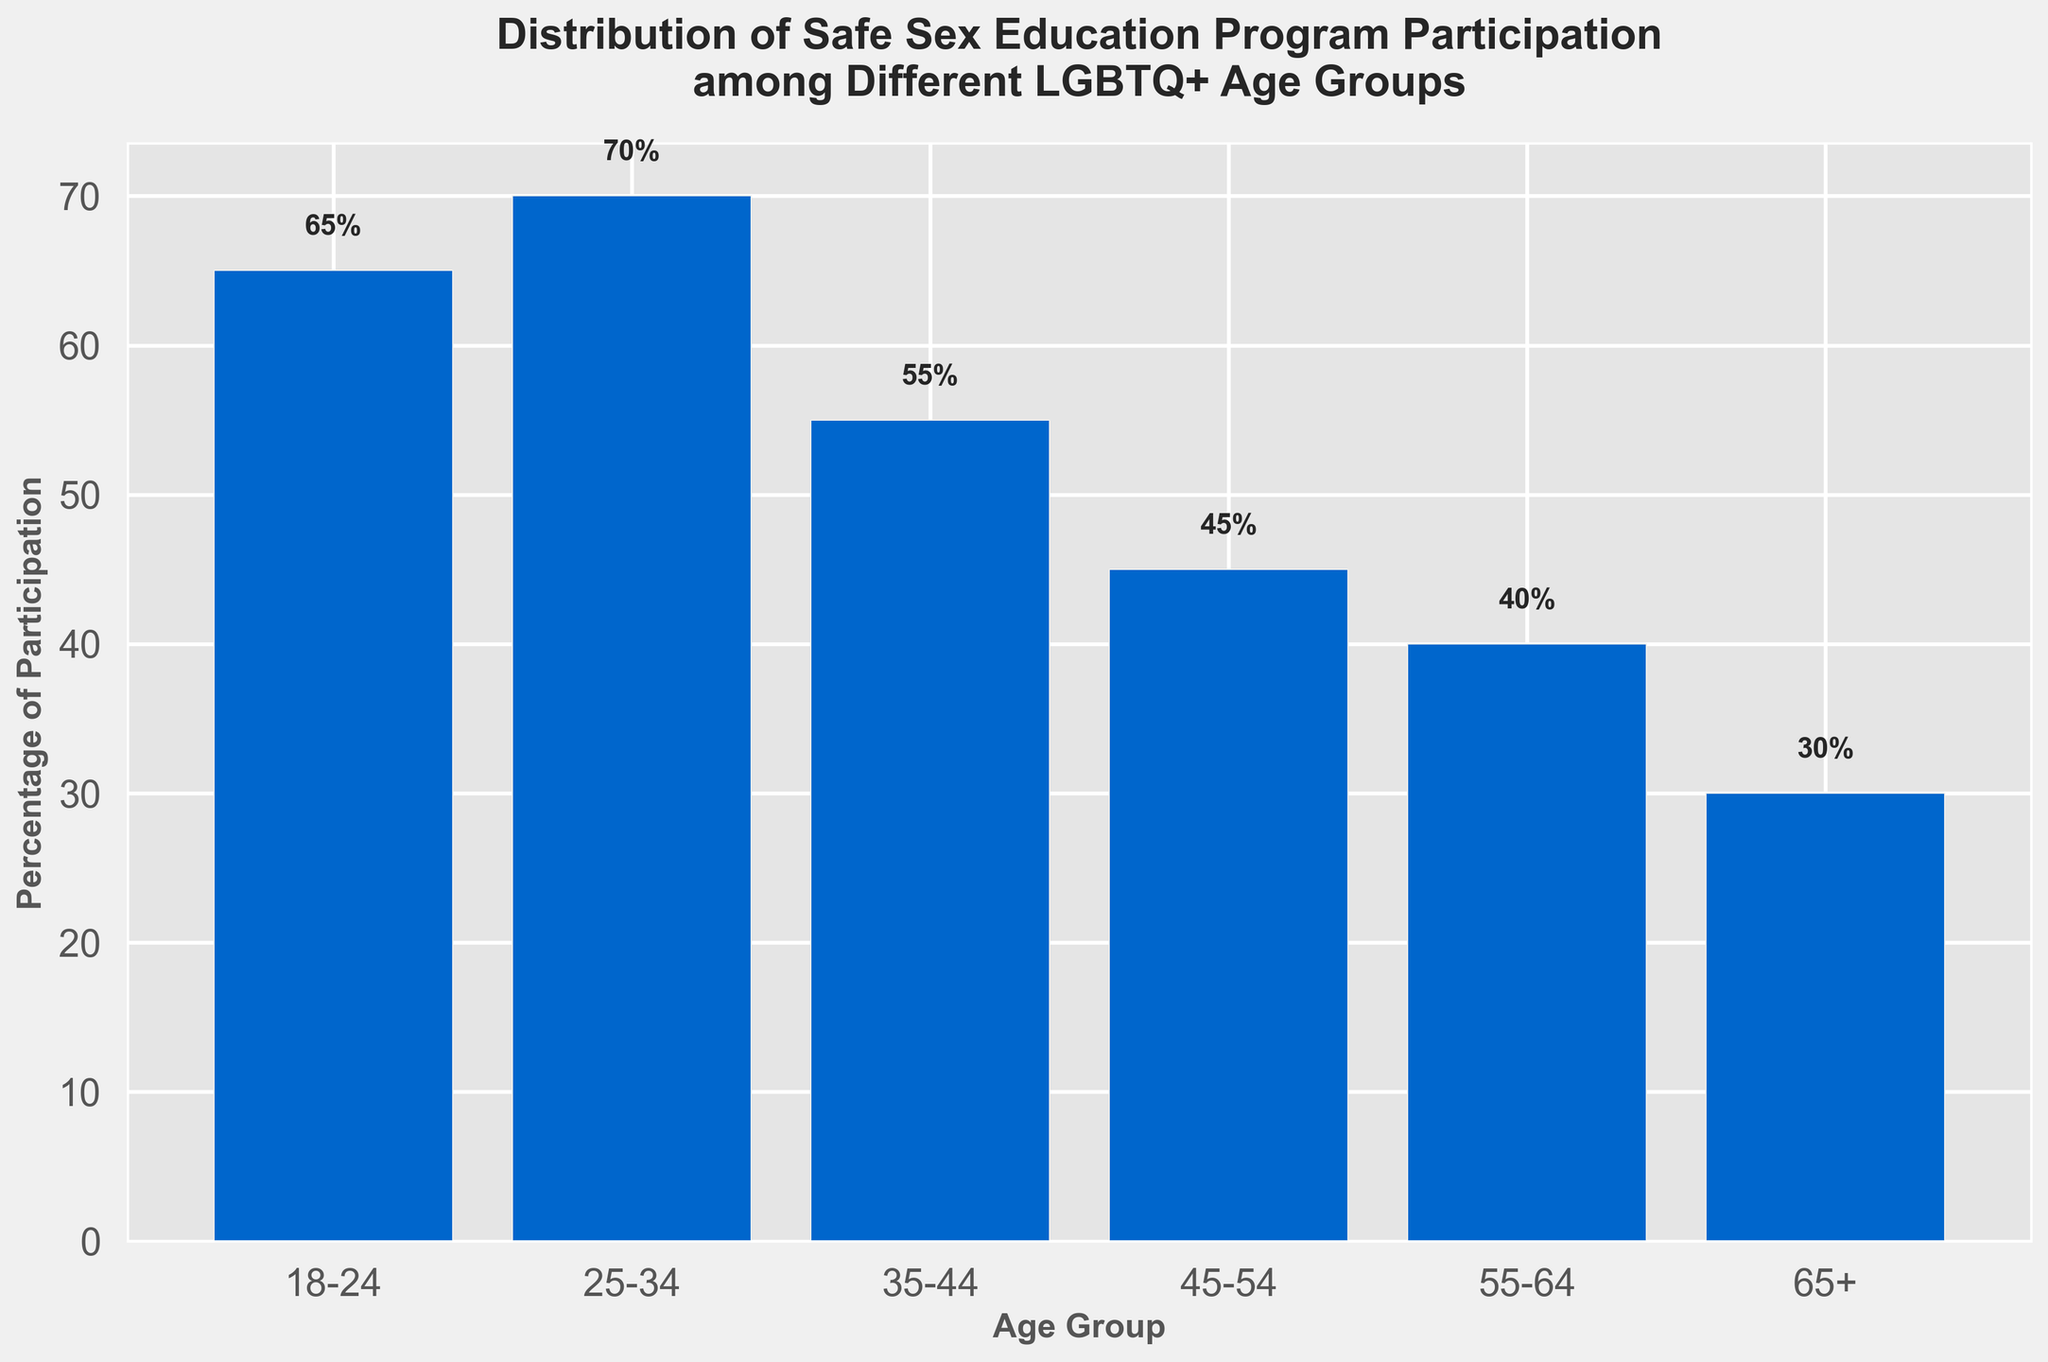What age group has the highest percentage of participation? The bar for the 25-34 age group is the tallest, reaching up to 70%.
Answer: 25-34 What is the difference in participation percentage between the 18-24 and 65+ age groups? The percentage for 18-24 is 65%, and 65+ is 30%. The difference is calculated as 65% - 30%.
Answer: 35% Which age group has a lower participation percentage, 45-54 or 55-64? The bar for the 55-64 age group is shorter than the bar for the 45-54 age group, indicating a lower percentage.
Answer: 55-64 What is the total participation percentage of the age groups 35-44, 45-54, and 55-64? Add the percentages: 55% (35-44) + 45% (45-54) + 40% (55-64) = 140%.
Answer: 140% How does the participation percentage of the 25-34 age group compare to the average participation percentage of all age groups? First, find the average participation by summing all age groups: (65 + 70 + 55 + 45 + 40 + 30) = 305, then divide by 6 (number of groups): 305/6 = 50.83%. The 25-34 group has a higher percentage at 70%.
Answer: Higher What is the visual difference between the bars representing the 18-24 and 35-44 age groups? The bar for the 18-24 age group is taller than the bar for the 35-44 age group, indicating a higher participation percentage for the former.
Answer: Taller What is the approximate gap in percentage participation between the age groups 35-44 and 45-54? The bar for the 35-44 is 55% and for the 45-54 is 45%. The approximate gap is found by calculating 55% - 45%.
Answer: 10% What is the average participation percentage for age groups under 45? The average is calculated by summing the percentages for the 18-24, 25-34, and 35-44 groups and dividing by 3: (65 + 70 + 55) / 3 = 63.33%.
Answer: 63.33% Which age group has the smallest participation percentage, and what is it? The shortest bar represents the 65+ age group, which has a 30% participation percentage.
Answer: 65+, 30% If you combine the age groups 45-54 and 55-64, what is their total participation percentage? Add the percentages for the 45-54 and 55-64 groups: 45% + 40% = 85%.
Answer: 85% 